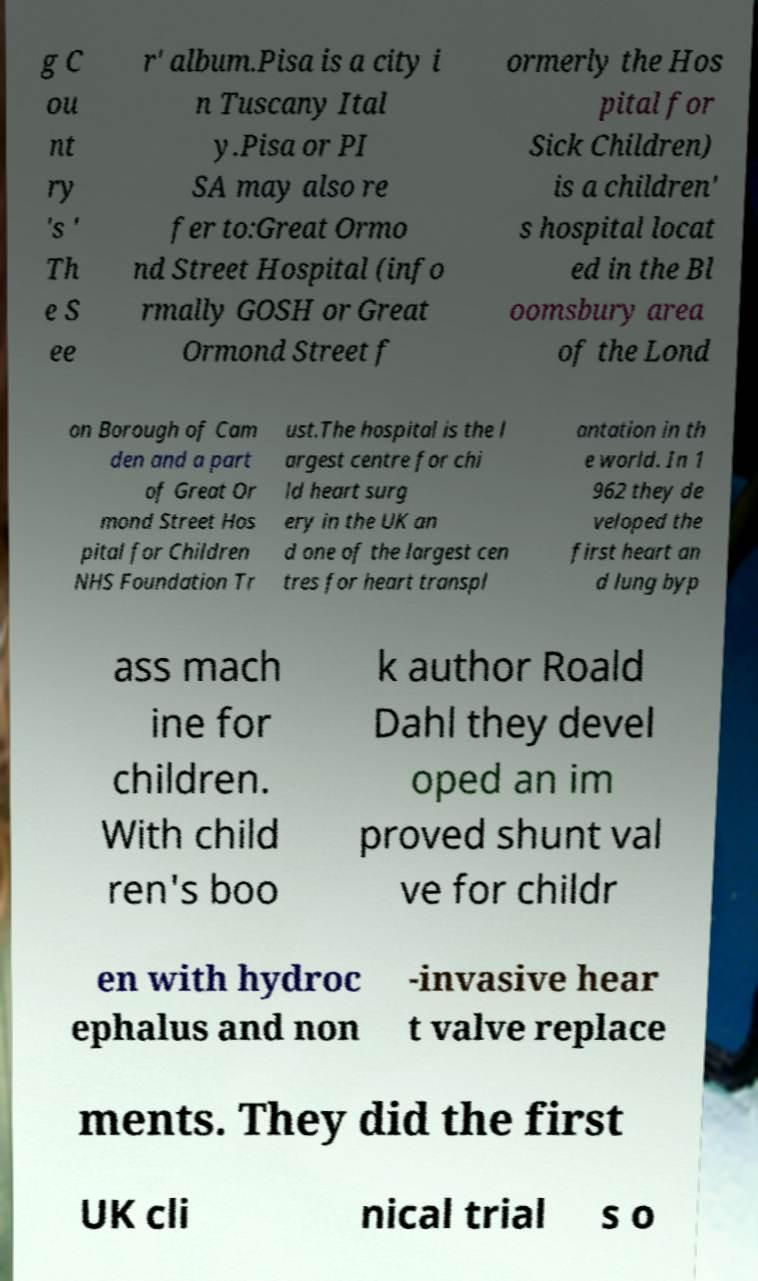I need the written content from this picture converted into text. Can you do that? g C ou nt ry 's ' Th e S ee r' album.Pisa is a city i n Tuscany Ital y.Pisa or PI SA may also re fer to:Great Ormo nd Street Hospital (info rmally GOSH or Great Ormond Street f ormerly the Hos pital for Sick Children) is a children' s hospital locat ed in the Bl oomsbury area of the Lond on Borough of Cam den and a part of Great Or mond Street Hos pital for Children NHS Foundation Tr ust.The hospital is the l argest centre for chi ld heart surg ery in the UK an d one of the largest cen tres for heart transpl antation in th e world. In 1 962 they de veloped the first heart an d lung byp ass mach ine for children. With child ren's boo k author Roald Dahl they devel oped an im proved shunt val ve for childr en with hydroc ephalus and non -invasive hear t valve replace ments. They did the first UK cli nical trial s o 